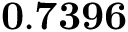<formula> <loc_0><loc_0><loc_500><loc_500>0 . 7 3 9 6</formula> 